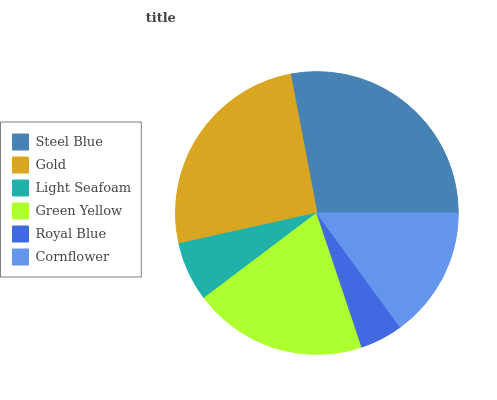Is Royal Blue the minimum?
Answer yes or no. Yes. Is Steel Blue the maximum?
Answer yes or no. Yes. Is Gold the minimum?
Answer yes or no. No. Is Gold the maximum?
Answer yes or no. No. Is Steel Blue greater than Gold?
Answer yes or no. Yes. Is Gold less than Steel Blue?
Answer yes or no. Yes. Is Gold greater than Steel Blue?
Answer yes or no. No. Is Steel Blue less than Gold?
Answer yes or no. No. Is Green Yellow the high median?
Answer yes or no. Yes. Is Cornflower the low median?
Answer yes or no. Yes. Is Gold the high median?
Answer yes or no. No. Is Gold the low median?
Answer yes or no. No. 